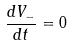Convert formula to latex. <formula><loc_0><loc_0><loc_500><loc_500>\frac { d V _ { - } } { d t } = 0</formula> 